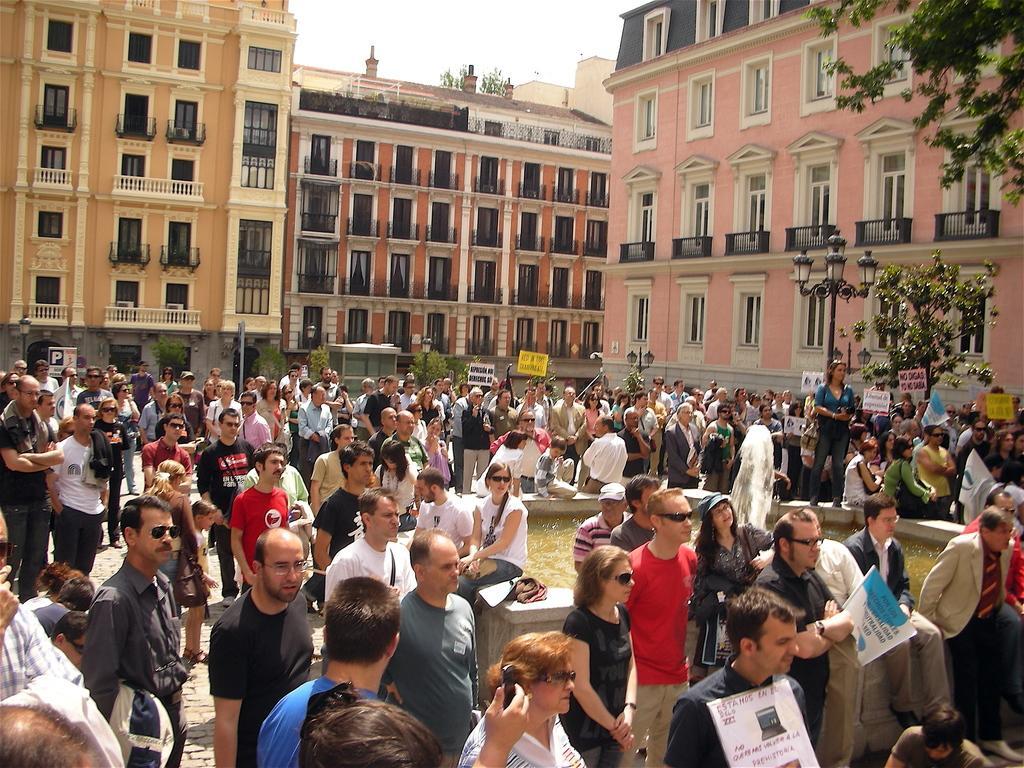Could you give a brief overview of what you see in this image? In this picture we can see a few people holding objects in their hands. We can see a fountain and water in the small pond. There are a few plants visible on the left side. We can see some buildings in the background. There is the sky on top of the picture. 